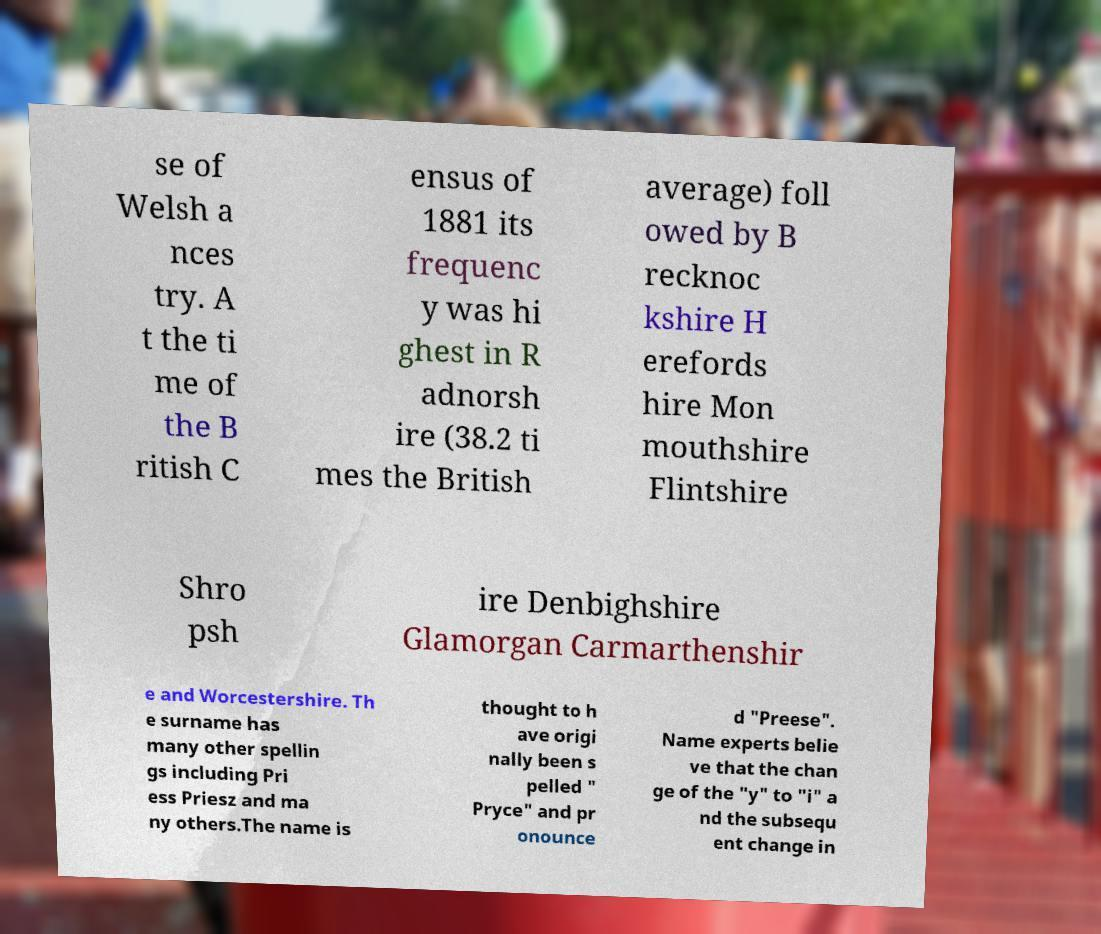Could you extract and type out the text from this image? se of Welsh a nces try. A t the ti me of the B ritish C ensus of 1881 its frequenc y was hi ghest in R adnorsh ire (38.2 ti mes the British average) foll owed by B recknoc kshire H erefords hire Mon mouthshire Flintshire Shro psh ire Denbighshire Glamorgan Carmarthenshir e and Worcestershire. Th e surname has many other spellin gs including Pri ess Priesz and ma ny others.The name is thought to h ave origi nally been s pelled " Pryce" and pr onounce d "Preese". Name experts belie ve that the chan ge of the "y" to "i" a nd the subsequ ent change in 